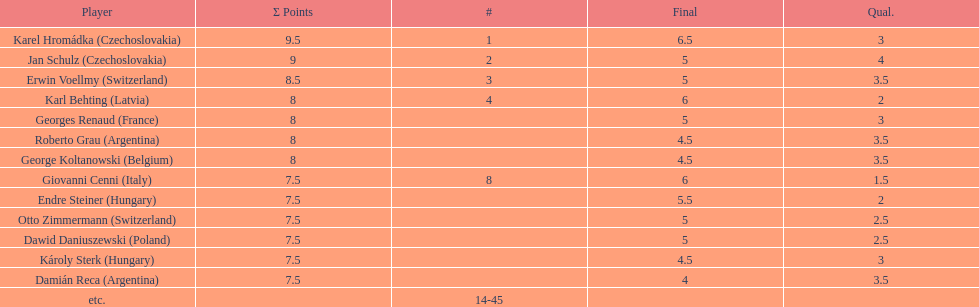Who was the top scorer from switzerland? Erwin Voellmy. 